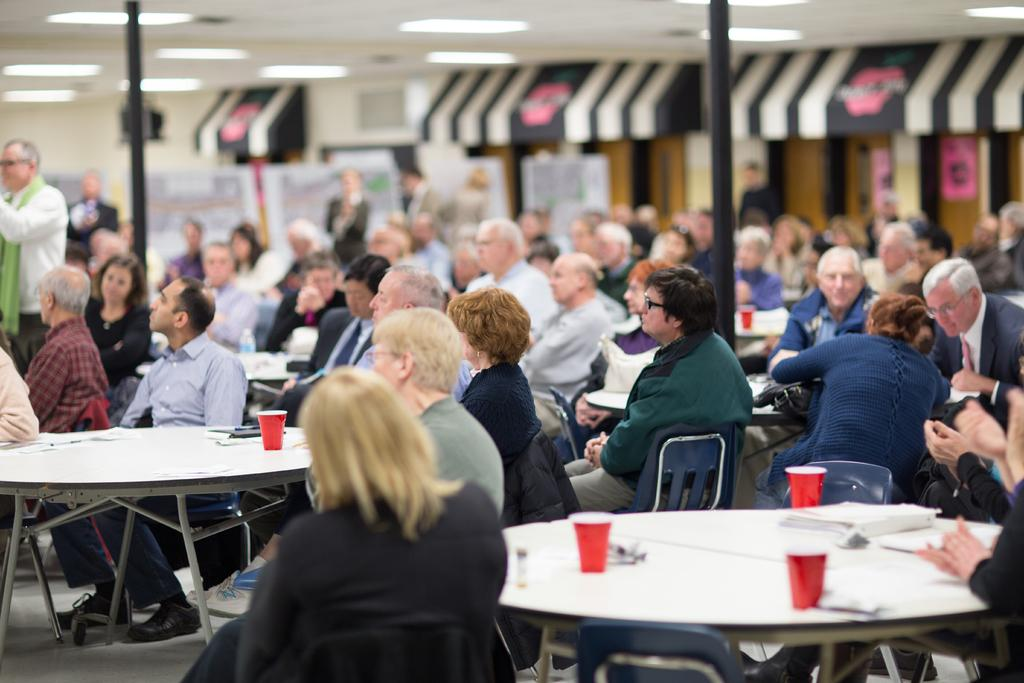What are the people in the image doing? There is a group of people sitting on chairs. What is in front of the chairs? There is a table in front of the chairs. What can be seen on the table? There are glasses on the table. What is the position of the person in the image? There is a person standing. What can be seen in terms of illumination in the image? There are lights visible. What type of frame is being used to start a race in the image? There is no frame or race present in the image; it features a group of people sitting on chairs with a standing person and a table with glasses. 